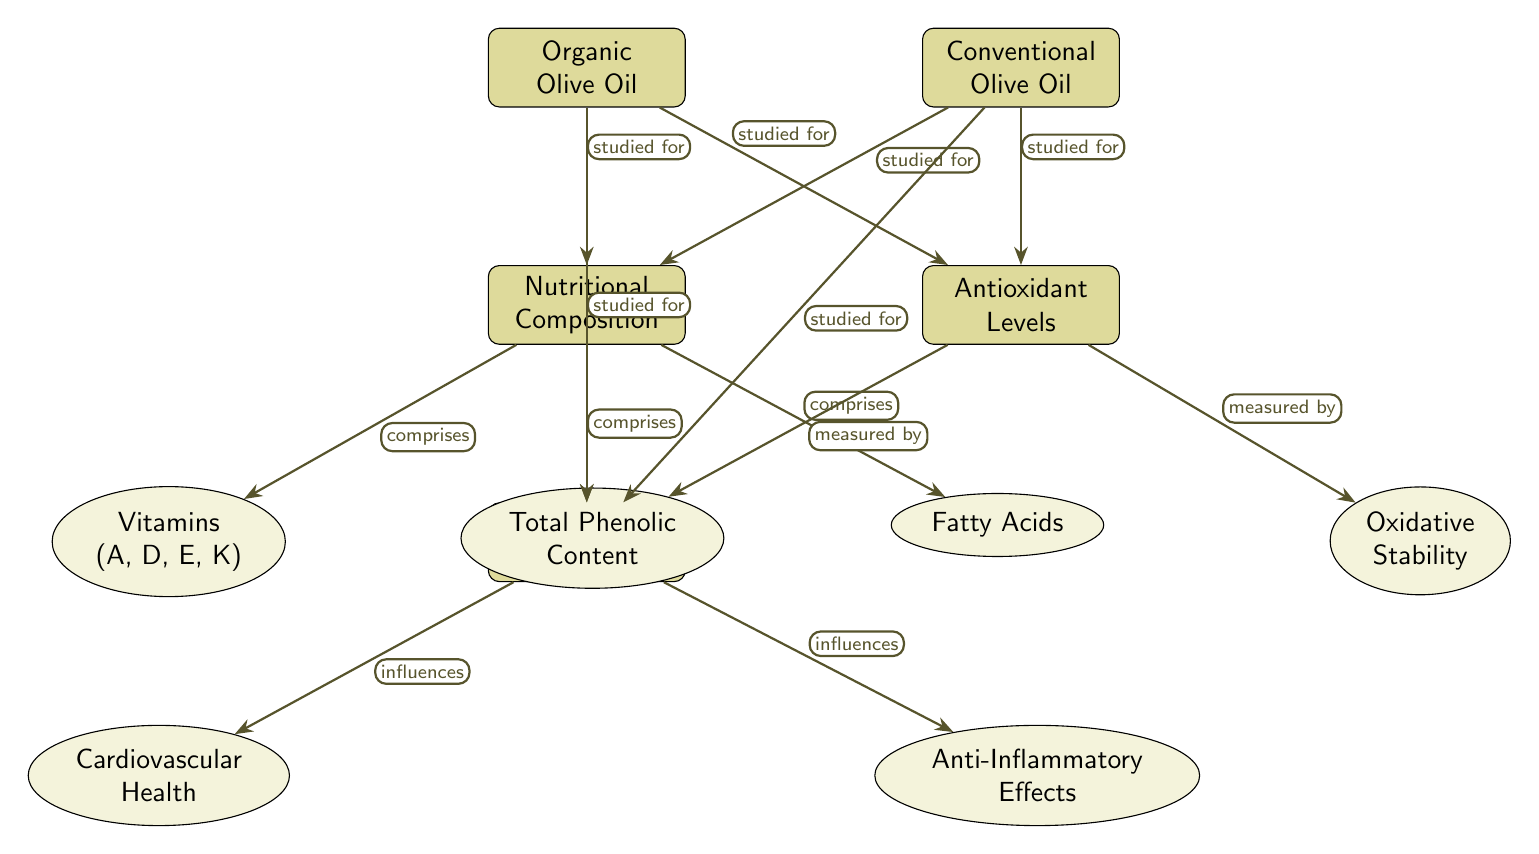What are the main types of olive oil studied? The diagram identifies two main types: Organic Olive Oil and Conventional Olive Oil, as indicated by the two main nodes on the top.
Answer: Organic Olive Oil, Conventional Olive Oil What factors are listed under Nutritional Composition? The nodes beneath Nutritional Composition include Vitamins (A, D, E, K), Polyphenols, and Fatty Acids, which are the components that comprise the nutritional profile of the oils.
Answer: Vitamins (A, D, E, K), Polyphenols, Fatty Acids How many health outcomes are indicated in the diagram? The diagram lists two health outcomes: Cardiovascular Health and Anti-Inflammatory Effects, as seen in the nodes below Health Outcomes.
Answer: 2 What is measured by Total Phenolic Content? Total Phenolic Content is specified in the diagram as an indicator used to measure Antioxidant Levels, represented by an edge that connects them.
Answer: Antioxidant Levels Which olive oil type is associated with Cardiovascular Health? Both Organic Olive Oil and Conventional Olive Oil are studied for their influence on Cardiovascular Health, as indicated by the directed edges from both main olive oil types to the Health Outcomes node.
Answer: Both Olive Oils What nutritional component is unique to Organic Olive Oil? The diagram does not provide a specific component that is unique to Organic Olive Oil, thus implying that while differences may exist, they are not explicitly detailed in the diagram.
Answer: None specified What does the edge from Nutritional Composition to Vitamins indicate? The edge labeled "comprises" indicates that Vitamins (A, D, E, K) are components that make up the Nutritional Composition of olive oils.
Answer: Comprises Vitamins What influences the relationship between Health Outcomes and the two olive oils? Both olive oils influence Health Outcomes, highlighting that the health benefits are connected through the nutritional profiles and antioxidant levels, as demonstrated by the links depicted in the diagram.
Answer: Both influence Health Outcomes 